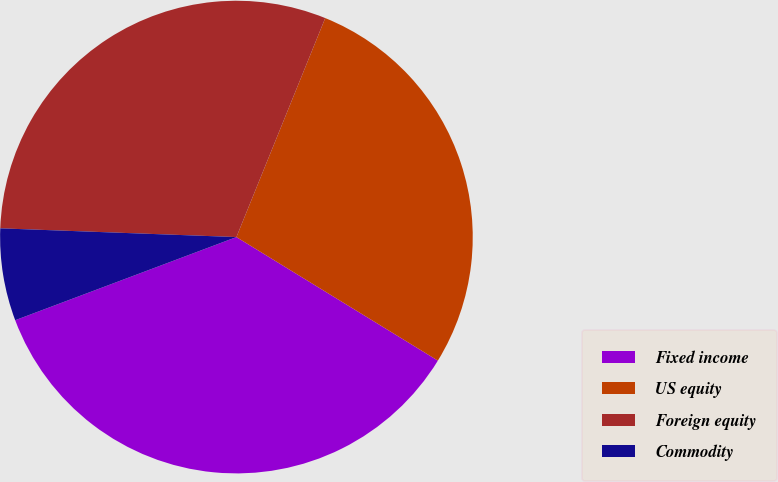Convert chart to OTSL. <chart><loc_0><loc_0><loc_500><loc_500><pie_chart><fcel>Fixed income<fcel>US equity<fcel>Foreign equity<fcel>Commodity<nl><fcel>35.52%<fcel>27.62%<fcel>30.54%<fcel>6.31%<nl></chart> 